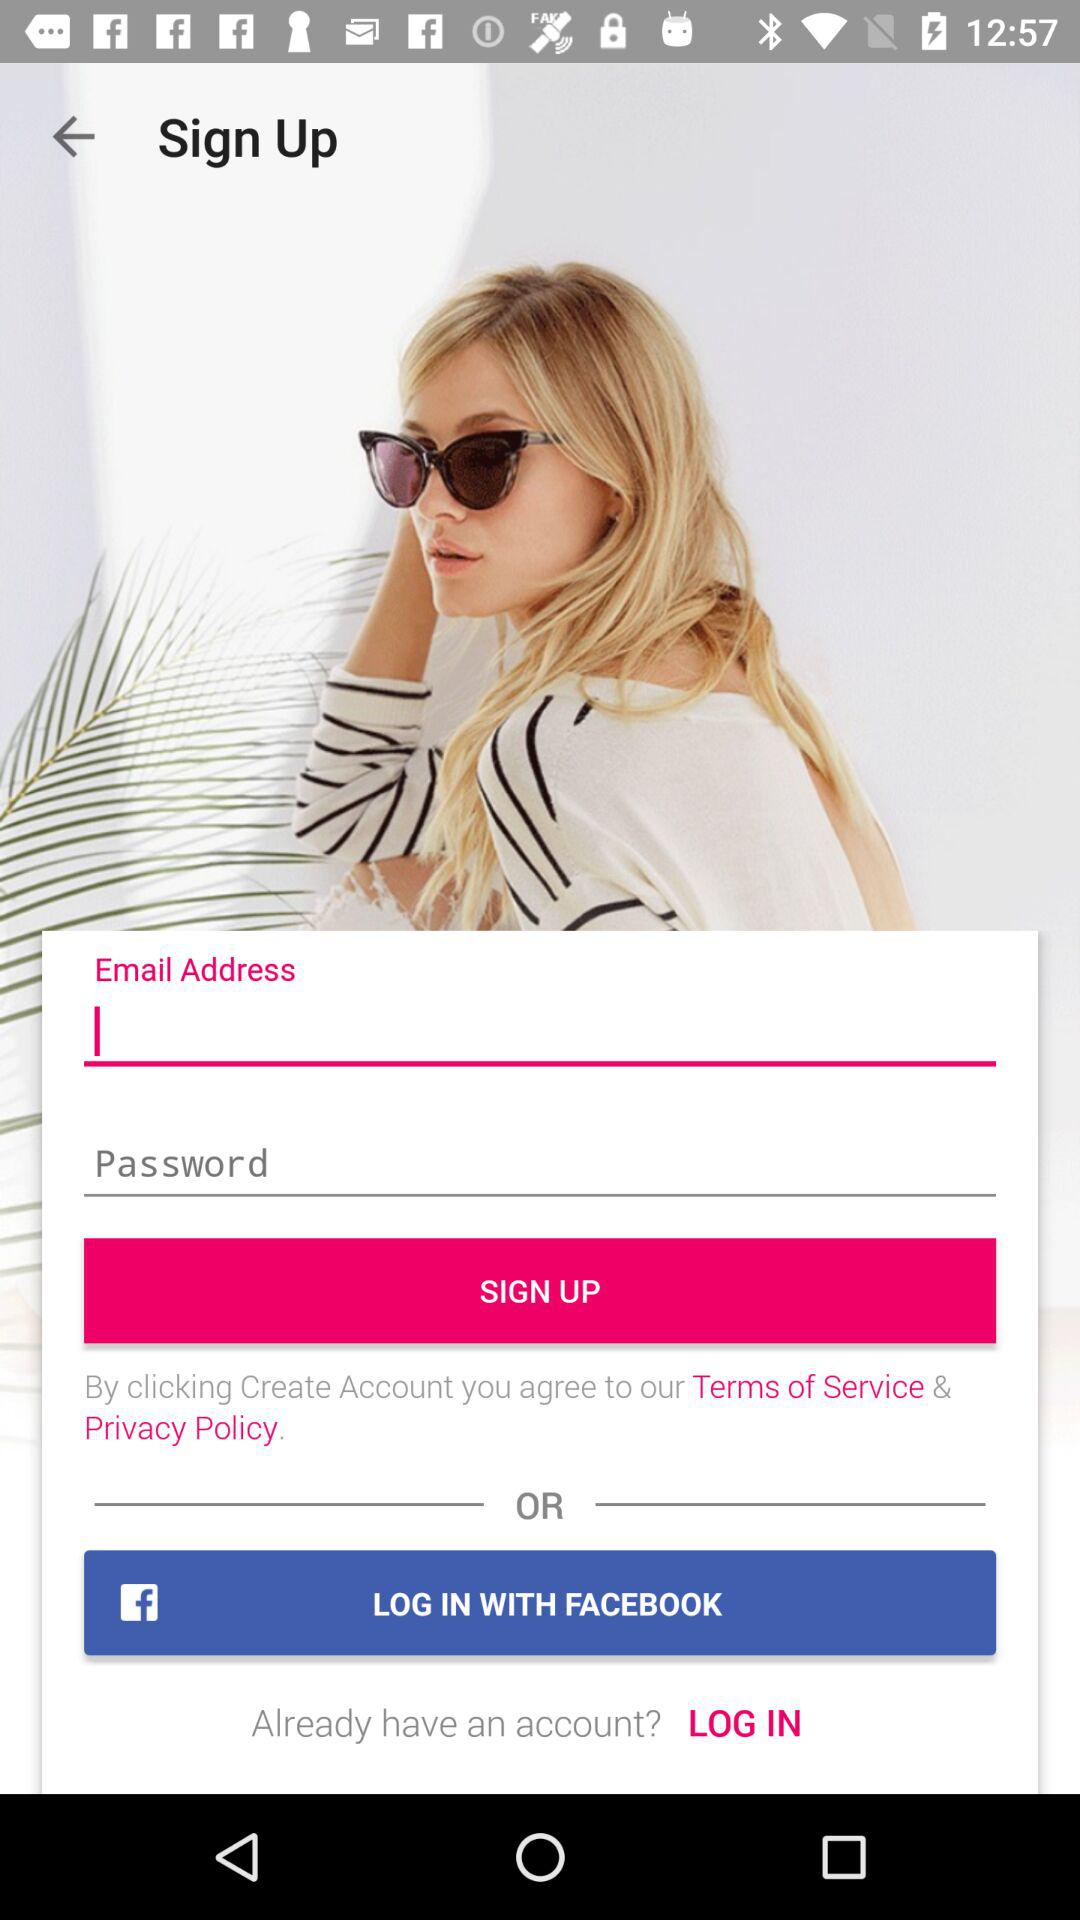How many fields do I need to fill in to sign up?
Answer the question using a single word or phrase. 2 